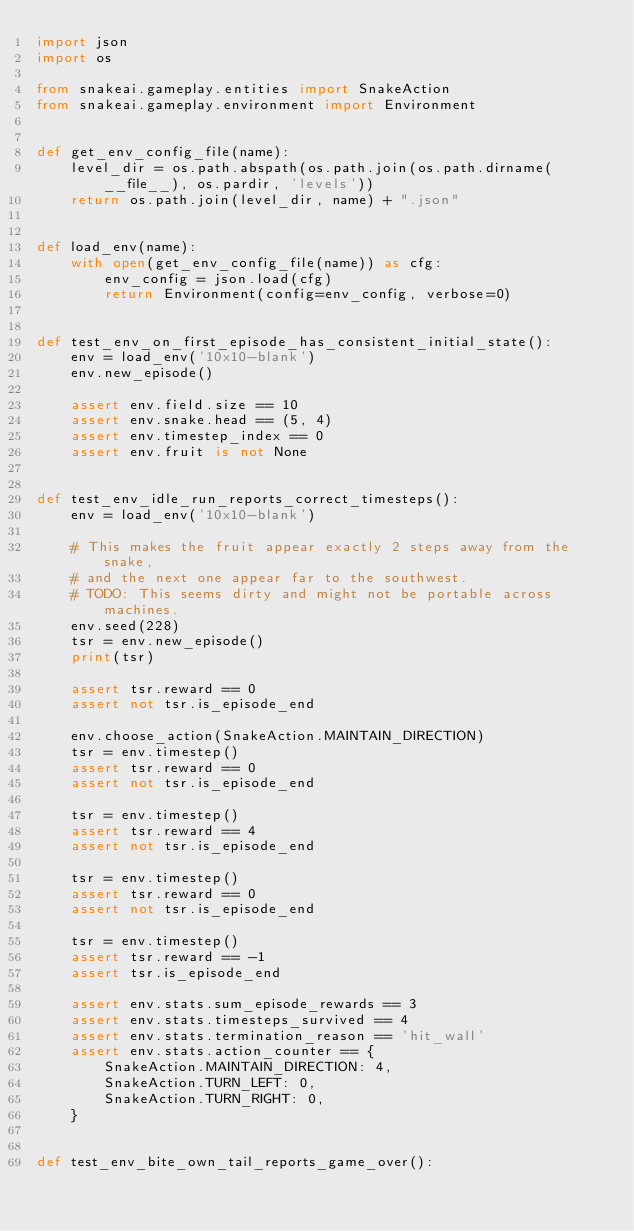<code> <loc_0><loc_0><loc_500><loc_500><_Python_>import json
import os

from snakeai.gameplay.entities import SnakeAction
from snakeai.gameplay.environment import Environment


def get_env_config_file(name):
    level_dir = os.path.abspath(os.path.join(os.path.dirname(__file__), os.pardir, 'levels'))
    return os.path.join(level_dir, name) + ".json"


def load_env(name):
    with open(get_env_config_file(name)) as cfg:
        env_config = json.load(cfg)
        return Environment(config=env_config, verbose=0)


def test_env_on_first_episode_has_consistent_initial_state():
    env = load_env('10x10-blank')
    env.new_episode()

    assert env.field.size == 10
    assert env.snake.head == (5, 4)
    assert env.timestep_index == 0
    assert env.fruit is not None


def test_env_idle_run_reports_correct_timesteps():
    env = load_env('10x10-blank')

    # This makes the fruit appear exactly 2 steps away from the snake,
    # and the next one appear far to the southwest.
    # TODO: This seems dirty and might not be portable across machines.
    env.seed(228)
    tsr = env.new_episode()
    print(tsr)

    assert tsr.reward == 0
    assert not tsr.is_episode_end

    env.choose_action(SnakeAction.MAINTAIN_DIRECTION)
    tsr = env.timestep()
    assert tsr.reward == 0
    assert not tsr.is_episode_end

    tsr = env.timestep()
    assert tsr.reward == 4
    assert not tsr.is_episode_end

    tsr = env.timestep()
    assert tsr.reward == 0
    assert not tsr.is_episode_end

    tsr = env.timestep()
    assert tsr.reward == -1
    assert tsr.is_episode_end

    assert env.stats.sum_episode_rewards == 3
    assert env.stats.timesteps_survived == 4
    assert env.stats.termination_reason == 'hit_wall'
    assert env.stats.action_counter == {
        SnakeAction.MAINTAIN_DIRECTION: 4,
        SnakeAction.TURN_LEFT: 0,
        SnakeAction.TURN_RIGHT: 0,
    }


def test_env_bite_own_tail_reports_game_over():</code> 